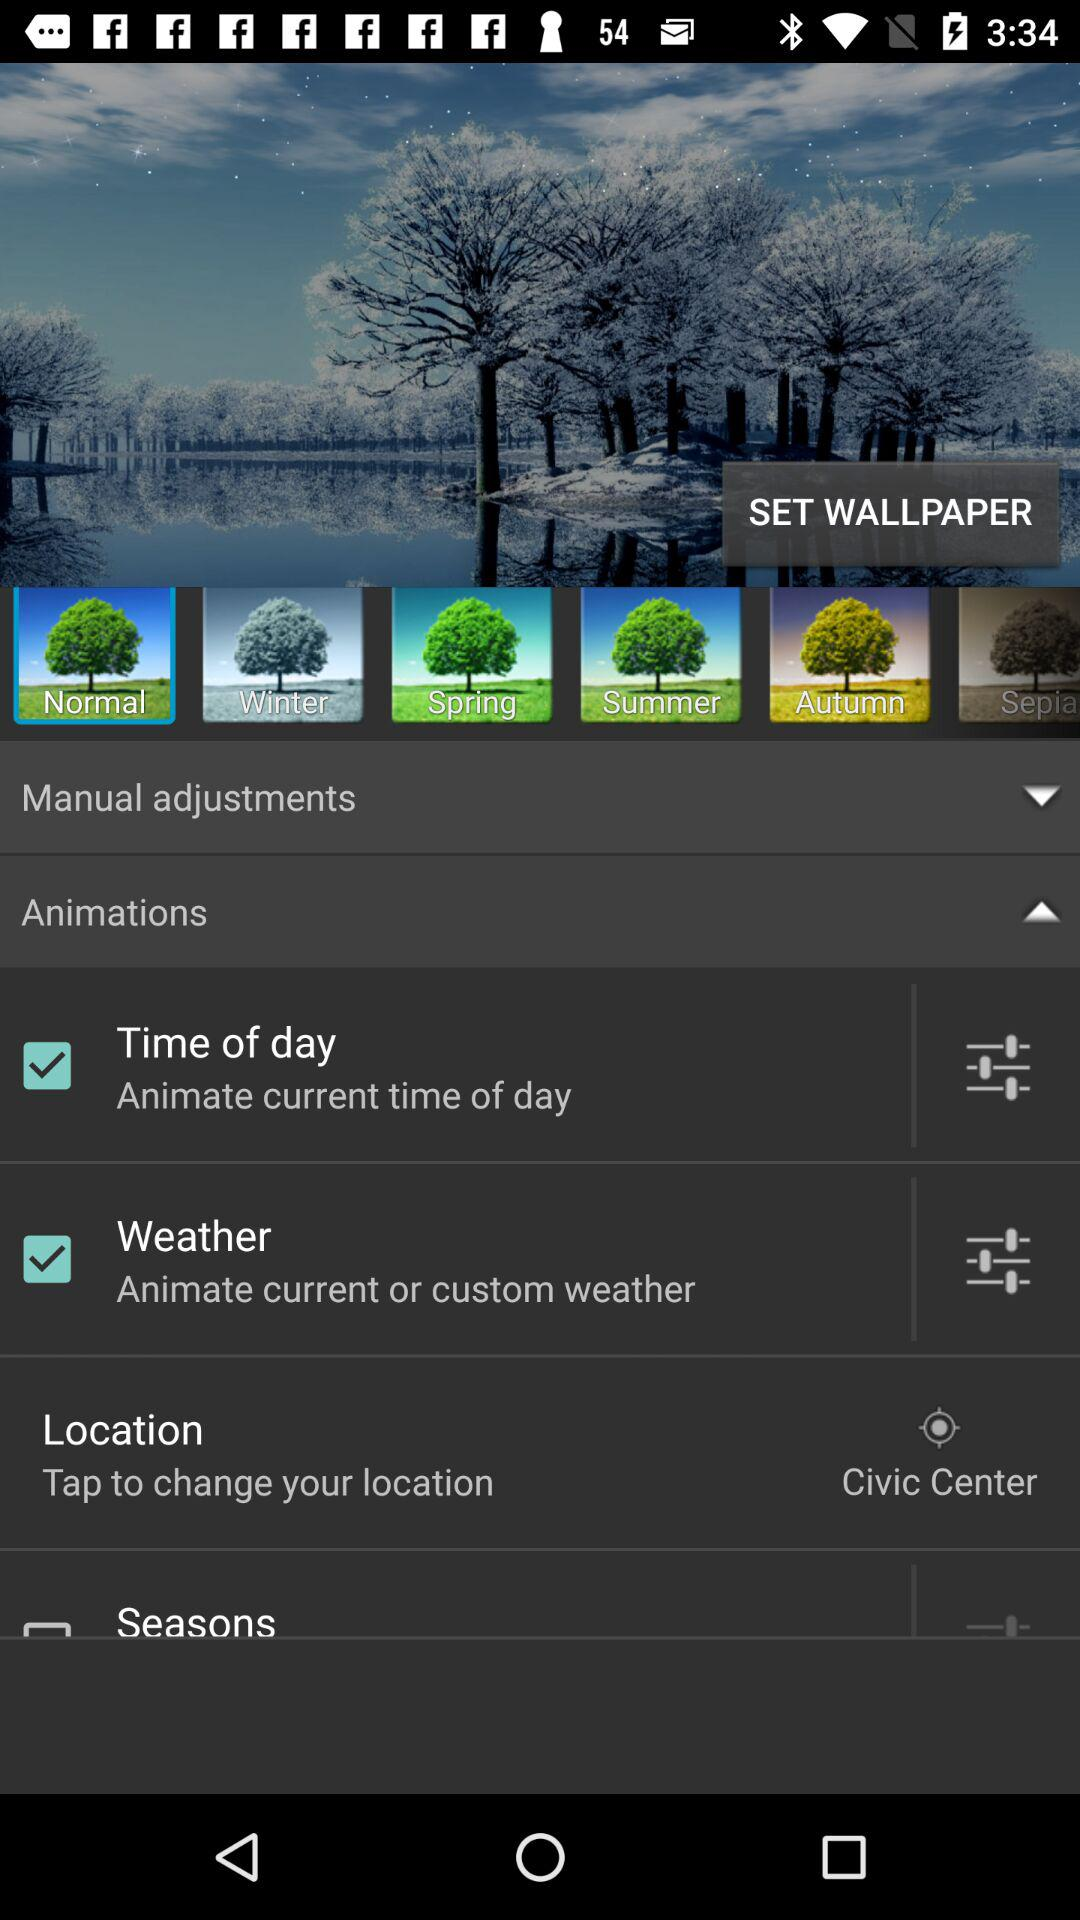What is my location? Your location is Civic Center. 